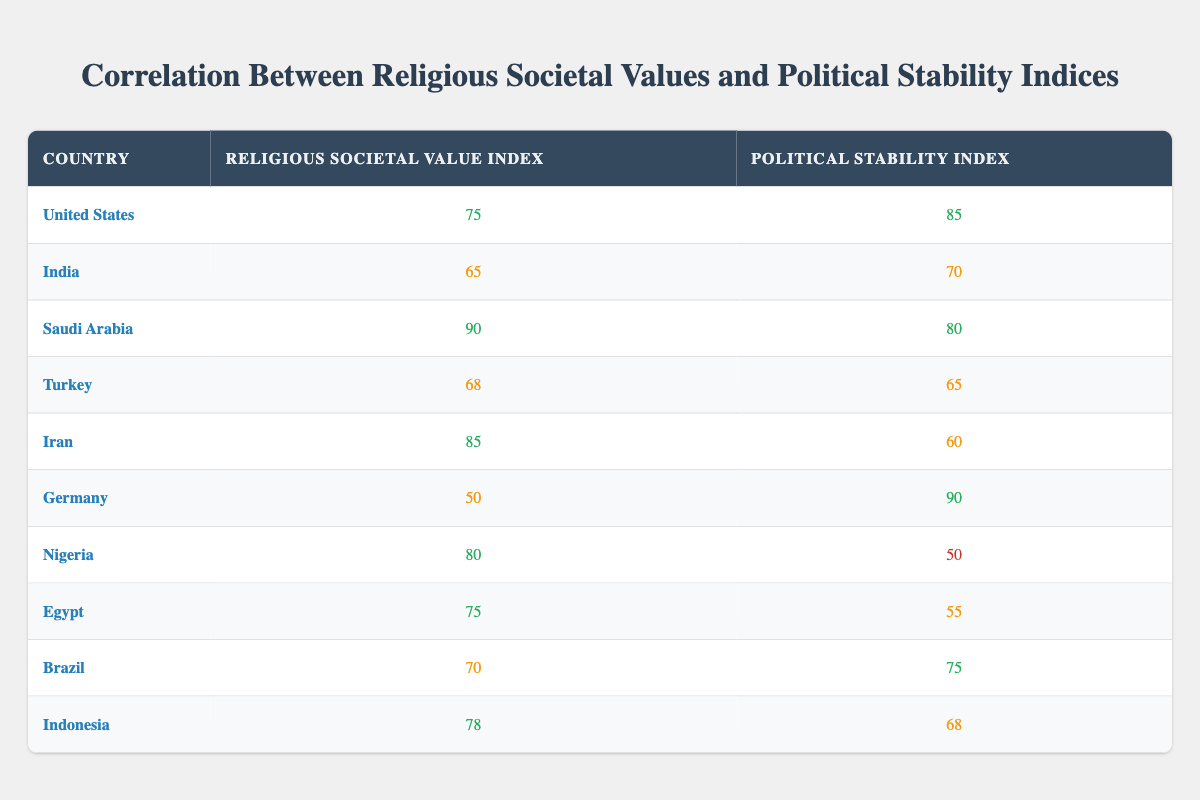What is the religious societal value index for Germany? The table shows that Germany has a religious societal value index of 50, listed under the corresponding country row.
Answer: 50 What is the political stability index of Nigeria? Looking at the row for Nigeria in the table, its political stability index is 50.
Answer: 50 Which country has the highest religious societal value index? By comparing the religious societal value indices, Saudi Arabia has the highest value at 90, as seen in its row.
Answer: Saudi Arabia What is the difference in religious societal value index between the United States and Turkey? The United States has a religious societal value index of 75 and Turkey has 68. Calculating the difference: 75 - 68 = 7.
Answer: 7 Is it true that Iran has a higher political stability index than Egypt? The political stability index for Iran is 60, while Egypt's is 55. Since 60 is greater than 55, this statement is true.
Answer: Yes What is the average political stability index of the countries listed? Summing the political stability indices: 85 (USA) + 70 (India) + 80 (Saudi Arabia) + 65 (Turkey) + 60 (Iran) + 90 (Germany) + 50 (Nigeria) + 55 (Egypt) + 75 (Brazil) + 68 (Indonesia) =  8 countries and dividing by 10 gives a total of 8, resulting in an average of 65.5.
Answer: 65.5 Which country has a religious societal value index lower than Turkey but a higher political stability index? Turkey has a religious societal value index of 68. Checking others, we find Germany (50 religious index) has a political stability index of 90 which is higher. Thus, Germany qualifies.
Answer: Germany Do both Brazil and India have political stability indices above average? The average political stability index found earlier is 65. Brazil has 75 (above average) while India has 70 (also above average), making the statement true.
Answer: Yes What is the sum of the religious societal value indices for Egypt and Indonesia? Summing the indices, Egypt has 75 and Indonesia has 78. Adding these gives: 75 + 78 = 153.
Answer: 153 